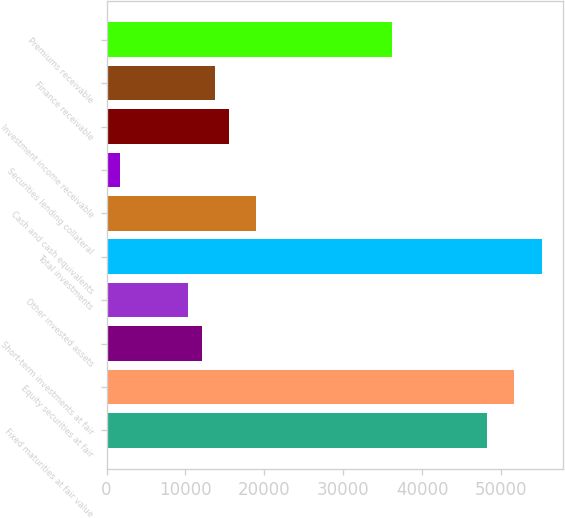Convert chart to OTSL. <chart><loc_0><loc_0><loc_500><loc_500><bar_chart><fcel>Fixed maturities at fair value<fcel>Equity securities at fair<fcel>Short-term investments at fair<fcel>Other invested assets<fcel>Total investments<fcel>Cash and cash equivalents<fcel>Securities lending collateral<fcel>Investment income receivable<fcel>Finance receivable<fcel>Premiums receivable<nl><fcel>48219.2<fcel>51663.3<fcel>12055.8<fcel>10333.8<fcel>55107.5<fcel>18944.1<fcel>1723.42<fcel>15500<fcel>13777.9<fcel>36164.7<nl></chart> 